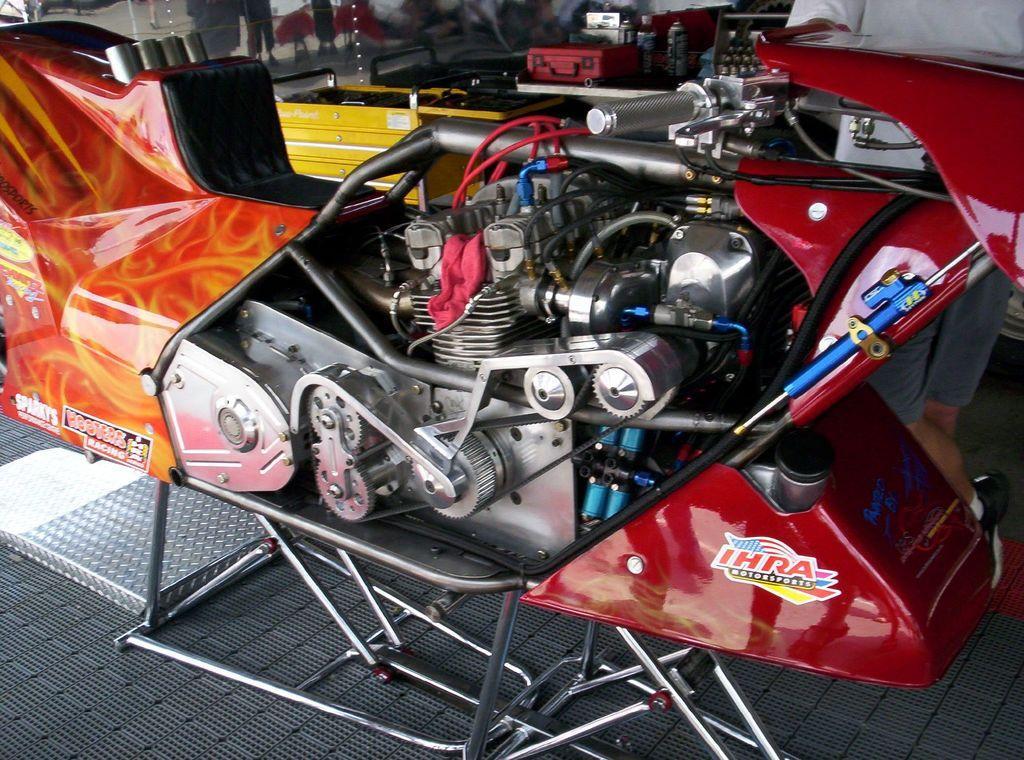Could you give a brief overview of what you see in this image? In this image there is a bike with engine in middle beside that there are some tool boxes. 